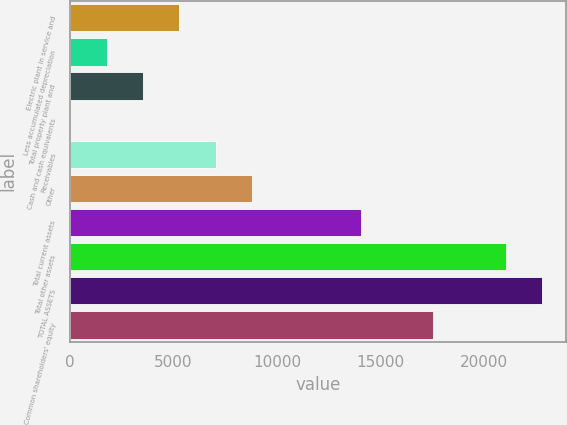<chart> <loc_0><loc_0><loc_500><loc_500><bar_chart><fcel>Electric plant in service and<fcel>Less accumulated depreciation<fcel>Total property plant and<fcel>Cash and cash equivalents<fcel>Receivables<fcel>Other<fcel>Total current assets<fcel>Total other assets<fcel>TOTAL ASSETS<fcel>Common shareholders' equity<nl><fcel>5271.5<fcel>1758.5<fcel>3515<fcel>2<fcel>7028<fcel>8784.5<fcel>14054<fcel>21080<fcel>22836.5<fcel>17567<nl></chart> 